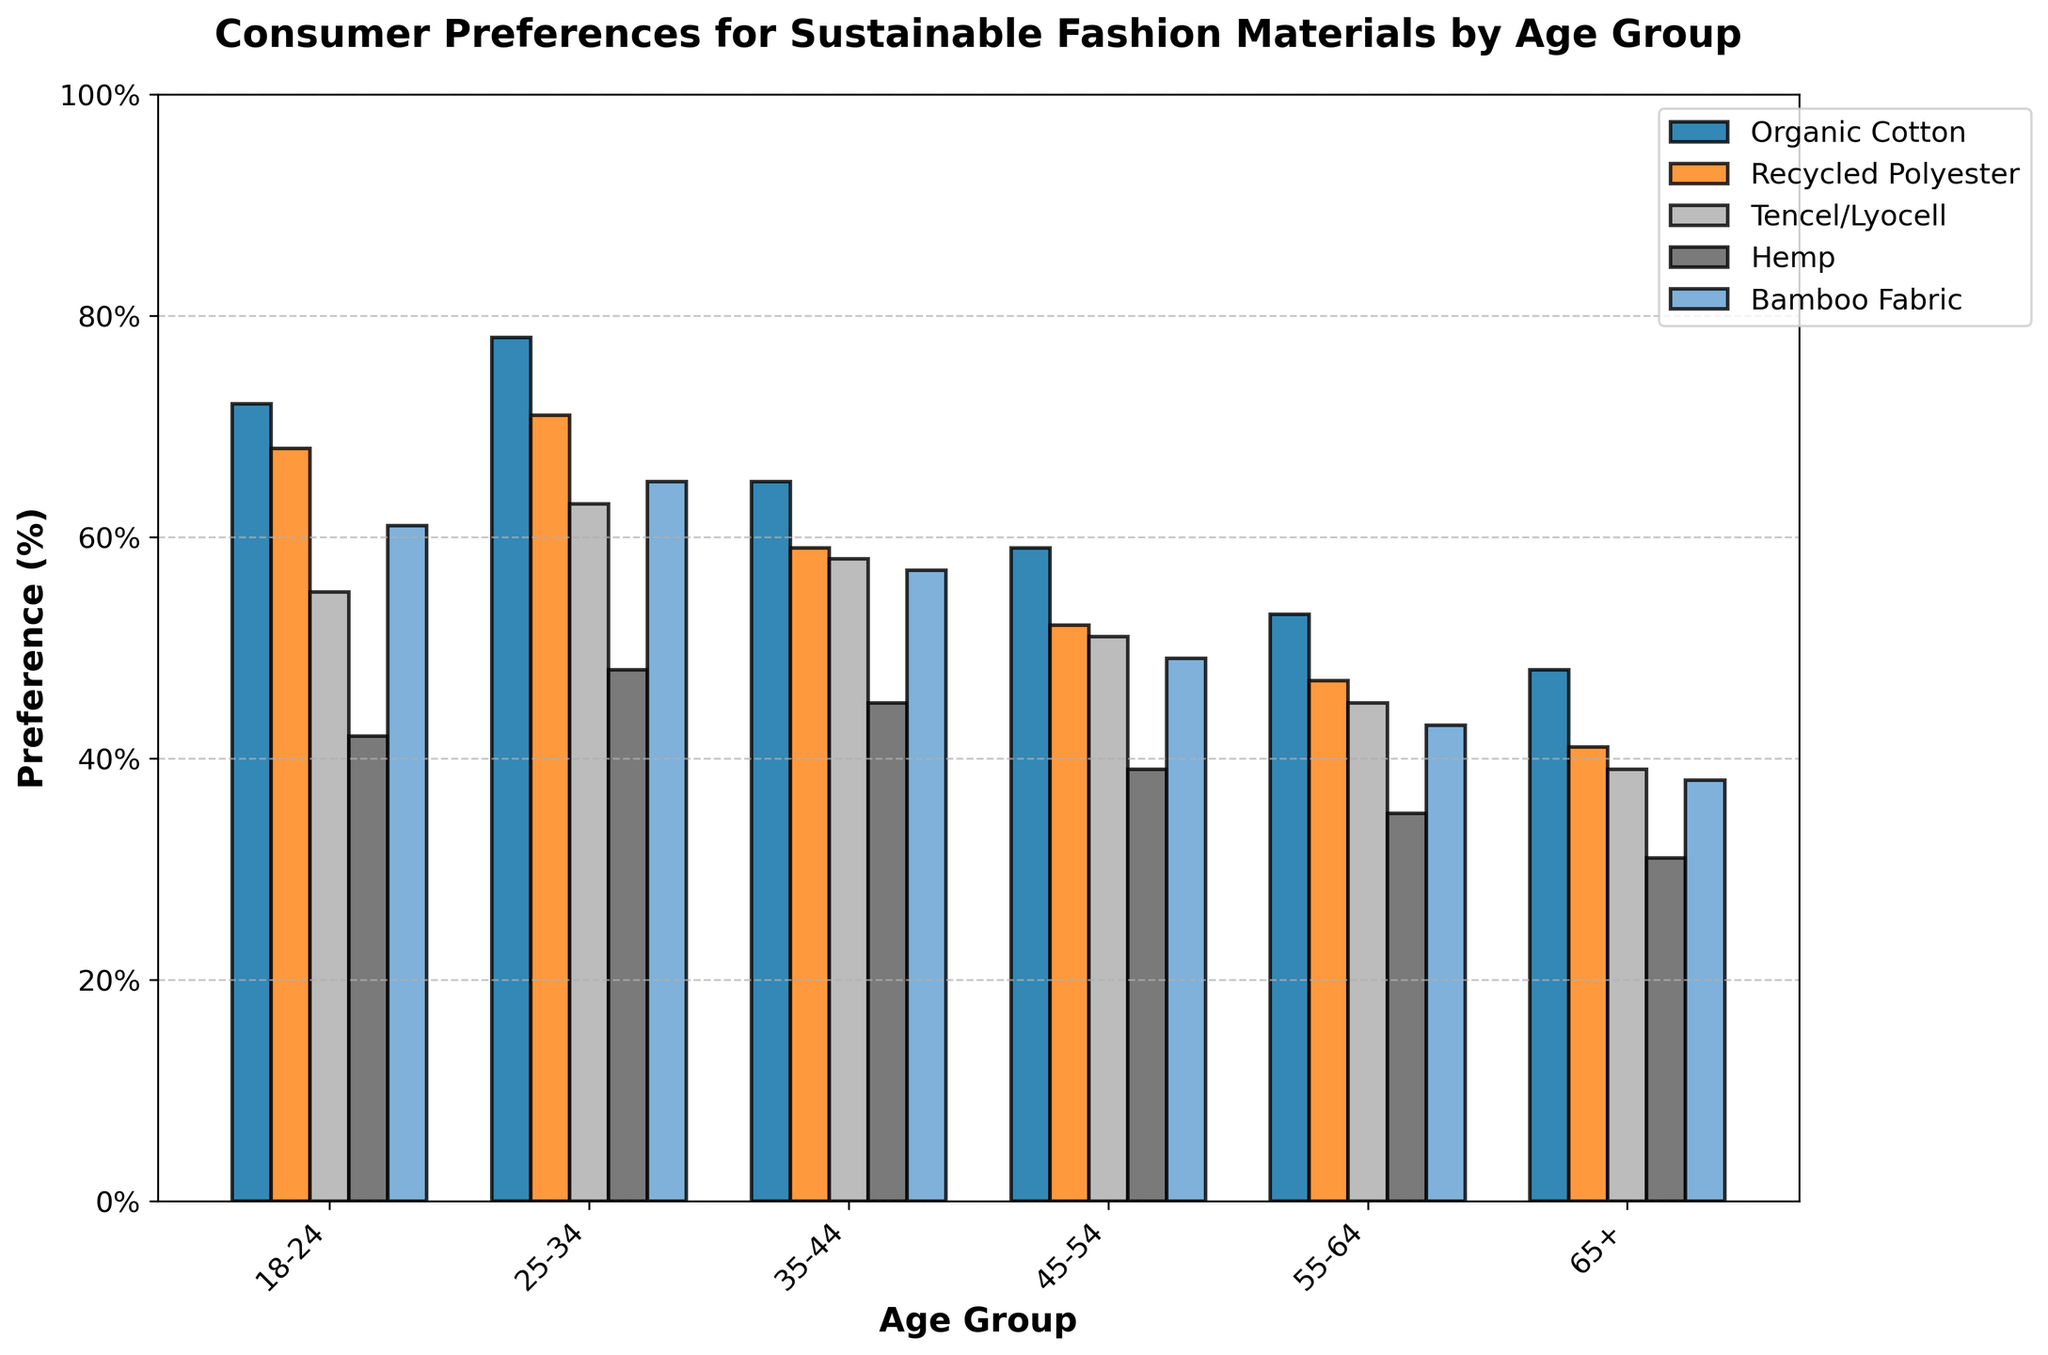What is the most preferred sustainable fashion material among the age group 18-24? Look at the heights of the bars for the age group 18-24. The highest bar represents the most preferred material.
Answer: Organic Cotton Which age group has the lowest preference for Bamboo Fabric? Compare the heights of the bars representing Bamboo Fabric across all age groups. The shortest bar indicates the lowest preference.
Answer: 65+ Which materials have a preference percentage above 60% for the age group 25-34? Find the bars for the age group 25-34 and see which ones are above the 60% mark on the y-axis.
Answer: Organic Cotton, Recycled Polyester, Tencel/Lyocell, Bamboo Fabric By how much percent does the preference for Organic Cotton decrease from the age group 25-34 to 55-64? Find the heights of the bars for Organic Cotton corresponding to 25-34 and 55-64 age groups. Subtract the latter from the former to get the difference (78% - 53% = 25%).
Answer: 25% Which sustainable material shows the smallest range of preference across all age groups? Calculate the range (difference between highest and lowest preferences) for each material. The material with the smallest range is the one with the least variation.
Answer: Tencel/Lyocell How does the preference for Recycled Polyester compare between the age groups 35-44 and 55-64? Look at the heights of the bars for Recycled Polyester in both age groups. Compare them to see which one is higher or if they are equal.
Answer: 35-44 has a higher preference What's the average preference percentage for Hemp across all age groups? Add up the preference percentages for Hemp across all age groups and divide by the number of age groups (42 + 48 + 45 + 39 + 35 + 31 = 240; 240/6 = 40%).
Answer: 40% Which two age groups show the closest preference for Tencel/Lyocell? Compare the heights of the bars for Tencel/Lyocell across all age groups. Identify the two groups with the closest heights.
Answer: 35-44 and 45-54 Is the preference for any sustainable material consistently decreasing as age increases? Which one? Look at the trend of the heights for each material across all age groups. Identify the material(s) that show a consistent downward trend.
Answer: Organic Cotton, Recycled Polyester, Bamboo Fabric What is the difference in preference percentage for Hemp between the youngest (18-24) and oldest (65+) age groups? Find the heights of the bars for Hemp corresponding to 18-24 and 65+ age groups. Subtract the latter from the former to get the difference (42% - 31% = 11%).
Answer: 11% 